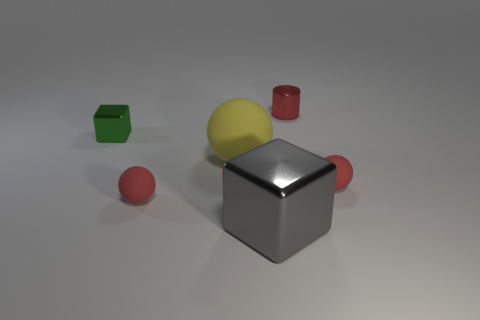There is a big thing that is behind the tiny matte object behind the small sphere left of the yellow thing; what is it made of?
Keep it short and to the point. Rubber. Is the number of small green blocks on the right side of the big sphere greater than the number of big shiny things in front of the red metal thing?
Provide a short and direct response. No. Is the size of the green object the same as the gray shiny cube?
Offer a terse response. No. There is a large metallic thing that is the same shape as the small green object; what color is it?
Your answer should be very brief. Gray. What number of tiny metal cubes are the same color as the large shiny cube?
Provide a succinct answer. 0. Are there more gray metal blocks on the right side of the big metal thing than big matte balls?
Your response must be concise. No. There is a metal cube behind the small red matte object on the right side of the gray cube; what color is it?
Offer a very short reply. Green. How many things are either tiny red balls that are on the left side of the gray shiny cube or matte spheres on the right side of the large sphere?
Make the answer very short. 2. What color is the small metallic cylinder?
Ensure brevity in your answer.  Red. How many tiny green objects are the same material as the cylinder?
Ensure brevity in your answer.  1. 